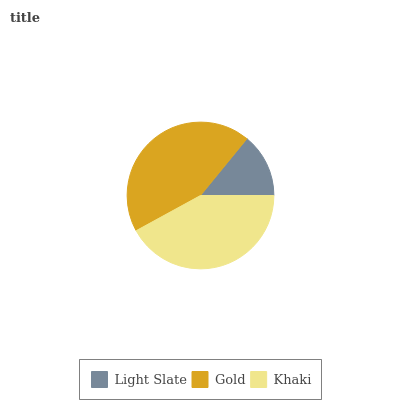Is Light Slate the minimum?
Answer yes or no. Yes. Is Gold the maximum?
Answer yes or no. Yes. Is Khaki the minimum?
Answer yes or no. No. Is Khaki the maximum?
Answer yes or no. No. Is Gold greater than Khaki?
Answer yes or no. Yes. Is Khaki less than Gold?
Answer yes or no. Yes. Is Khaki greater than Gold?
Answer yes or no. No. Is Gold less than Khaki?
Answer yes or no. No. Is Khaki the high median?
Answer yes or no. Yes. Is Khaki the low median?
Answer yes or no. Yes. Is Gold the high median?
Answer yes or no. No. Is Gold the low median?
Answer yes or no. No. 